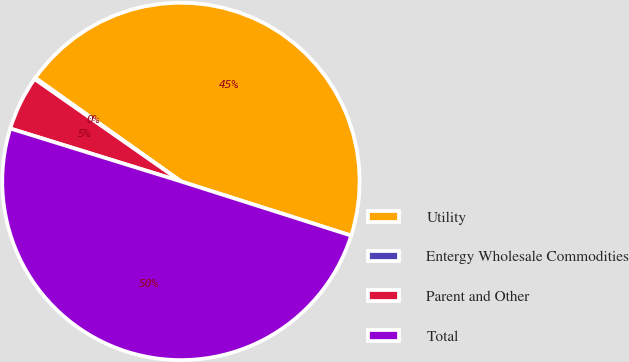<chart> <loc_0><loc_0><loc_500><loc_500><pie_chart><fcel>Utility<fcel>Entergy Wholesale Commodities<fcel>Parent and Other<fcel>Total<nl><fcel>45.07%<fcel>0.12%<fcel>4.93%<fcel>49.88%<nl></chart> 